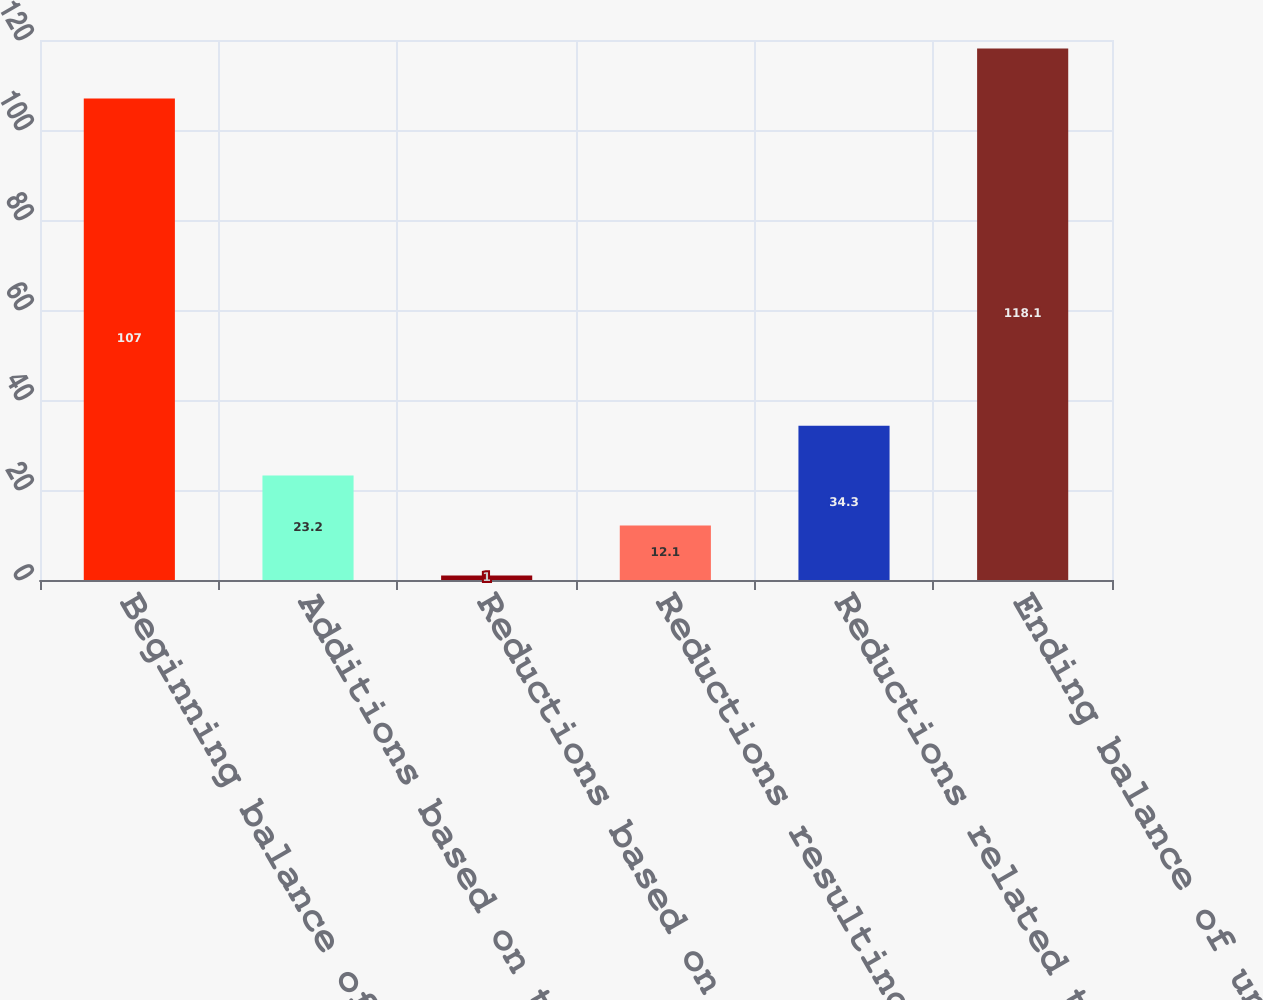Convert chart. <chart><loc_0><loc_0><loc_500><loc_500><bar_chart><fcel>Beginning balance of<fcel>Additions based on tax<fcel>Reductions based on tax<fcel>Reductions resulting from<fcel>Reductions related to<fcel>Ending balance of unrecognized<nl><fcel>107<fcel>23.2<fcel>1<fcel>12.1<fcel>34.3<fcel>118.1<nl></chart> 